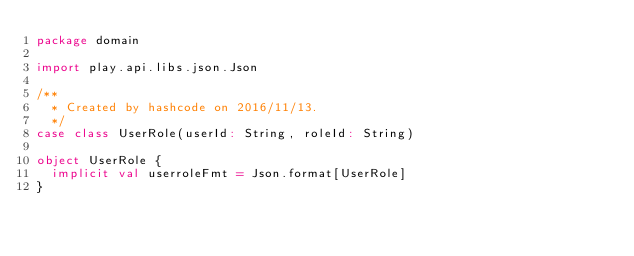<code> <loc_0><loc_0><loc_500><loc_500><_Scala_>package domain

import play.api.libs.json.Json

/**
  * Created by hashcode on 2016/11/13.
  */
case class UserRole(userId: String, roleId: String)

object UserRole {
  implicit val userroleFmt = Json.format[UserRole]
}
</code> 